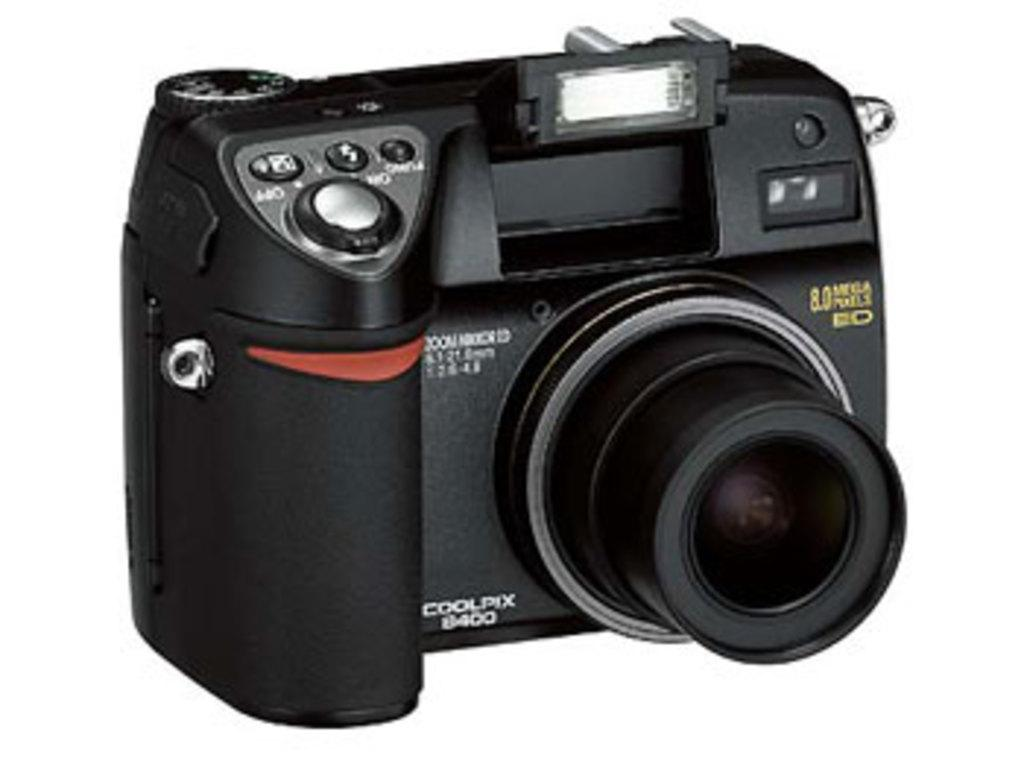What object is the main focus of the image? There is a camera in the image. Can you describe the color of the camera? The camera is black in color. What type of sweater is the government wearing in the image? There is no government or sweater present in the image; it only features a black camera. 